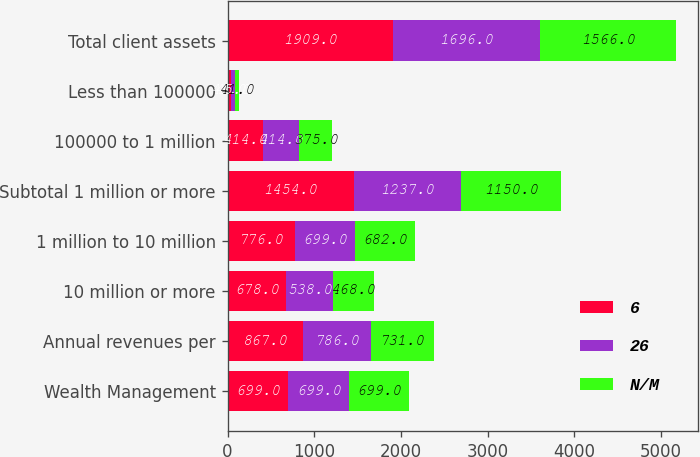Convert chart to OTSL. <chart><loc_0><loc_0><loc_500><loc_500><stacked_bar_chart><ecel><fcel>Wealth Management<fcel>Annual revenues per<fcel>10 million or more<fcel>1 million to 10 million<fcel>Subtotal 1 million or more<fcel>100000 to 1 million<fcel>Less than 100000<fcel>Total client assets<nl><fcel>6<fcel>699<fcel>867<fcel>678<fcel>776<fcel>1454<fcel>414<fcel>41<fcel>1909<nl><fcel>26<fcel>699<fcel>786<fcel>538<fcel>699<fcel>1237<fcel>414<fcel>45<fcel>1696<nl><fcel>N/M<fcel>699<fcel>731<fcel>468<fcel>682<fcel>1150<fcel>375<fcel>41<fcel>1566<nl></chart> 